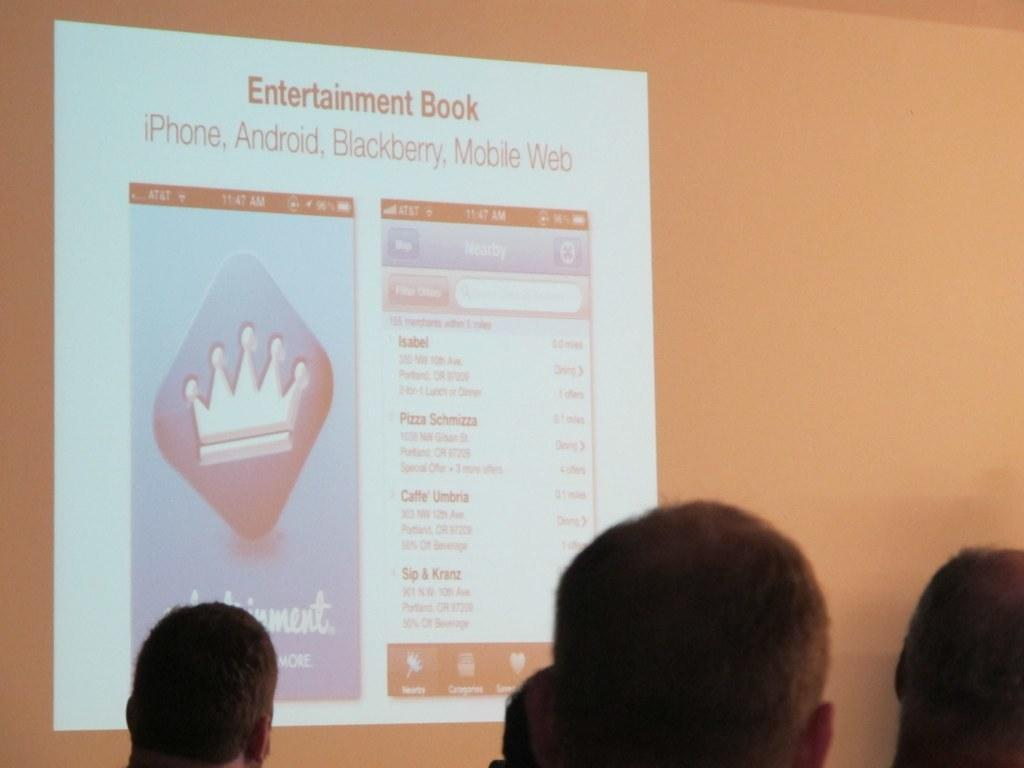How many people are in the image? There is a group of people in the image, but the exact number is not specified. What is the main focus of the group of people in the image? The group of people are gathered in front of a projector screen. What type of berry is being passed around by the passengers in the image? There is no mention of passengers or berries in the image; it features a group of people in front of a projector screen. 